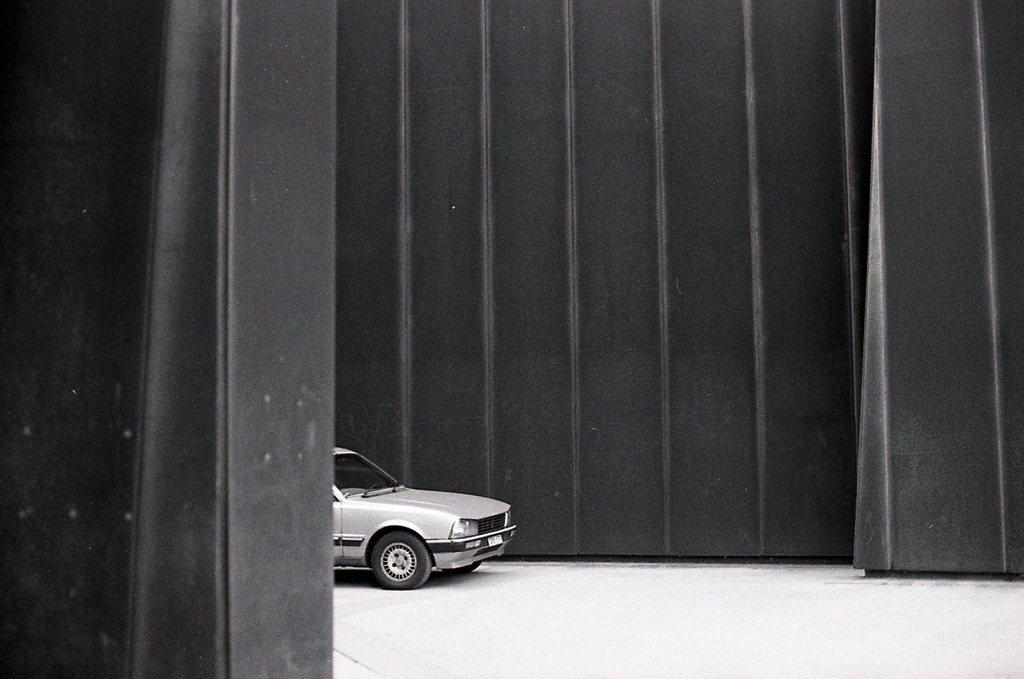What is the main subject of the image? The main subject of the image is a car. Where is the car located in the image? The car is on the floor in the image. What color is the wall in the background of the image? The wall in the background of the image is black. What is the color scheme of the image? The image is black and white. What type of vegetable is growing in the hole in the image? There is no vegetable or hole present in the image; it features a car on the floor with a black color wall in the background. 